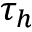Convert formula to latex. <formula><loc_0><loc_0><loc_500><loc_500>\tau _ { h }</formula> 